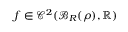<formula> <loc_0><loc_0><loc_500><loc_500>f \in \mathcal { C } ^ { 2 } ( \mathcal { B } _ { R } ( { \boldsymbol \rho } ) , \mathbb { R } )</formula> 